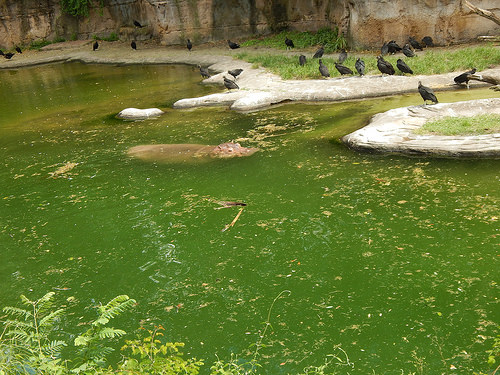<image>
Can you confirm if the algae is next to the vulture? Yes. The algae is positioned adjacent to the vulture, located nearby in the same general area. 